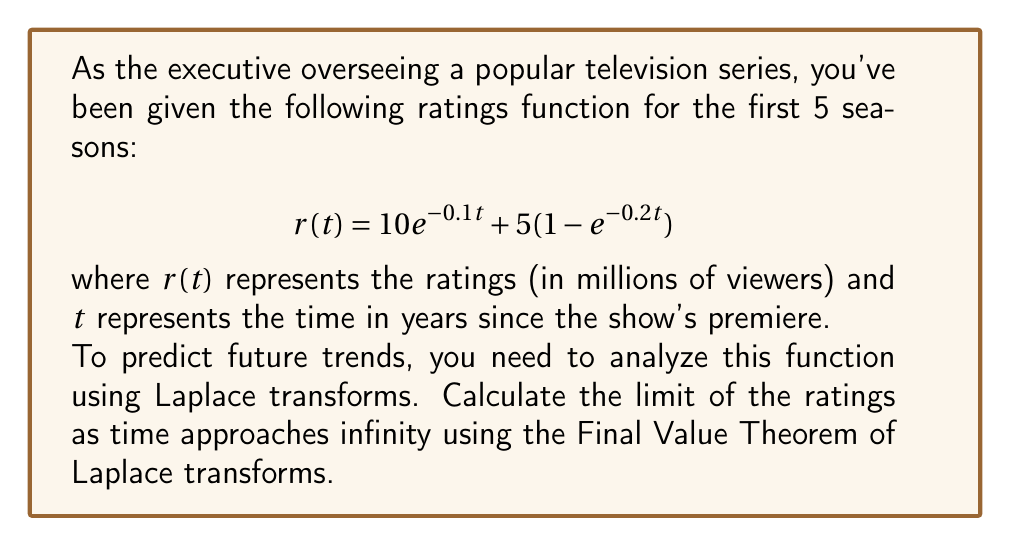Can you answer this question? To solve this problem using Laplace transforms, we'll follow these steps:

1) First, we need to take the Laplace transform of $r(t)$. Let's call this $R(s)$:

   $$R(s) = \mathcal{L}\{10e^{-0.1t} + 5(1-e^{-0.2t})\}$$

2) Using linearity and standard Laplace transform pairs:

   $$R(s) = 10\cdot\frac{1}{s+0.1} + 5\cdot\frac{1}{s} - 5\cdot\frac{1}{s+0.2}$$

3) The Final Value Theorem states that for a function $f(t)$ with Laplace transform $F(s)$:

   $$\lim_{t\to\infty} f(t) = \lim_{s\to 0} sF(s)$$

4) Applying this to our function:

   $$\lim_{t\to\infty} r(t) = \lim_{s\to 0} s\left(\frac{10}{s+0.1} + \frac{5}{s} - \frac{5}{s+0.2}\right)$$

5) Simplify:

   $$= \lim_{s\to 0} \left(\frac{10s}{s+0.1} + 5 - \frac{5s}{s+0.2}\right)$$

6) As $s$ approaches 0:

   $$= \frac{10\cdot 0}{0+0.1} + 5 - \frac{5\cdot 0}{0+0.2} = 0 + 5 - 0 = 5$$

Therefore, the limit of the ratings as time approaches infinity is 5 million viewers.
Answer: 5 million viewers 